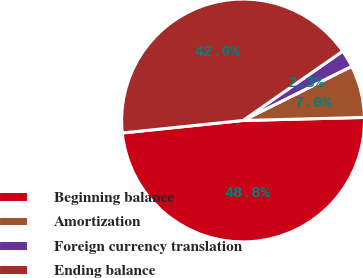Convert chart to OTSL. <chart><loc_0><loc_0><loc_500><loc_500><pie_chart><fcel>Beginning balance<fcel>Amortization<fcel>Foreign currency translation<fcel>Ending balance<nl><fcel>48.76%<fcel>6.96%<fcel>2.31%<fcel>41.97%<nl></chart> 